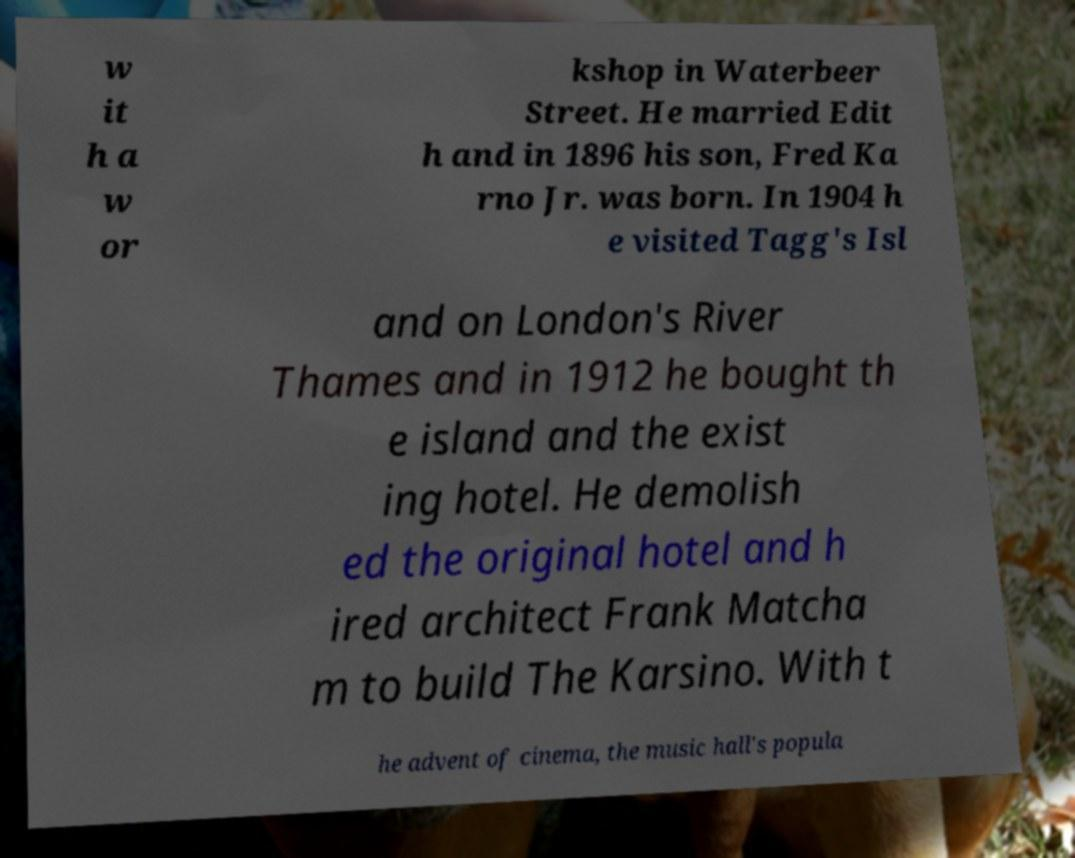For documentation purposes, I need the text within this image transcribed. Could you provide that? w it h a w or kshop in Waterbeer Street. He married Edit h and in 1896 his son, Fred Ka rno Jr. was born. In 1904 h e visited Tagg's Isl and on London's River Thames and in 1912 he bought th e island and the exist ing hotel. He demolish ed the original hotel and h ired architect Frank Matcha m to build The Karsino. With t he advent of cinema, the music hall's popula 